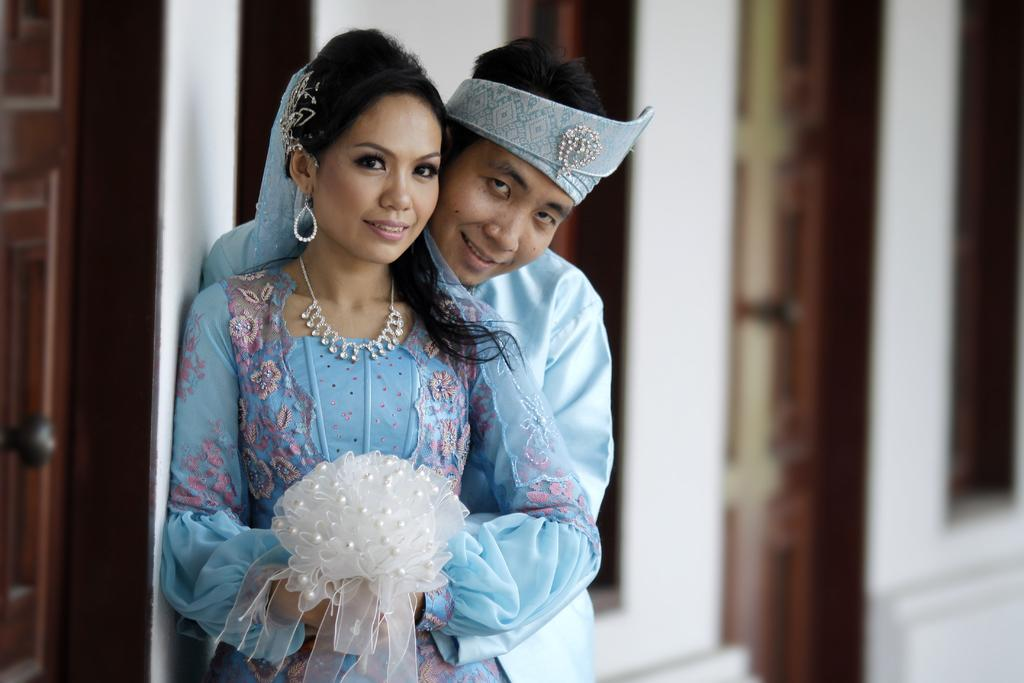What type of structure can be seen in the image? There is a wall in the image. Are there any openings in the wall? Yes, there is a door in the image. How many people are present in the image? There are two people in the image. What are the people wearing? The two people are wearing blue color dresses. What type of tax is being discussed by the two people in the image? There is no indication in the image that the two people are discussing any type of tax. 